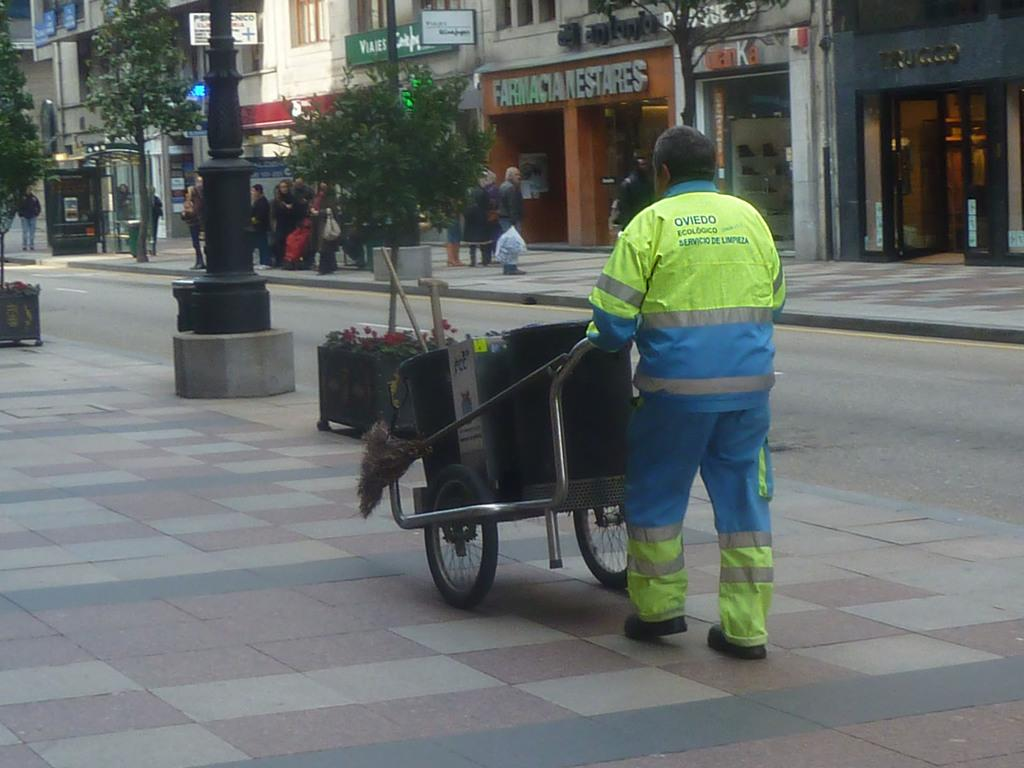What type of structures can be seen in the image? There are buildings in the image. What natural elements are present in the image? There are trees in the image. What object is used for waste disposal in the image? There is a dustbin in the image. What type of plants can be seen in the image? There are flowers in the image. Are there any living beings present in the image? Yes, there are people present in the image. What type of balloon is being used for religious purposes in the image? There is no balloon or religious activity present in the image. What type of show is being performed by the people in the image? There is no show or performance taking place in the image; the people are simply present. 